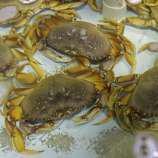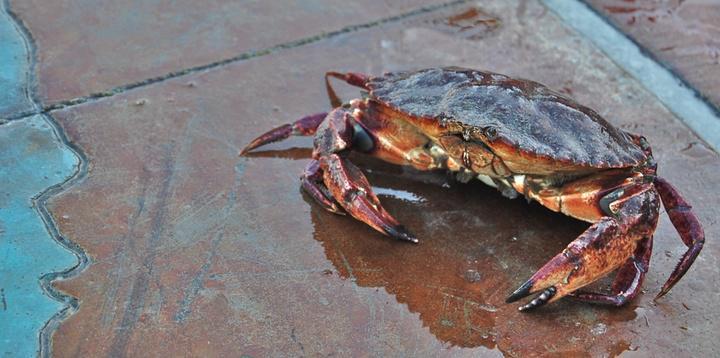The first image is the image on the left, the second image is the image on the right. Considering the images on both sides, is "One of the images features exactly one crab." valid? Answer yes or no. Yes. The first image is the image on the left, the second image is the image on the right. Examine the images to the left and right. Is the description "One image features one prominent forward-facing purple crab, and the other image features multiple crabs in a top-view." accurate? Answer yes or no. Yes. 